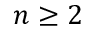Convert formula to latex. <formula><loc_0><loc_0><loc_500><loc_500>n \geq 2</formula> 